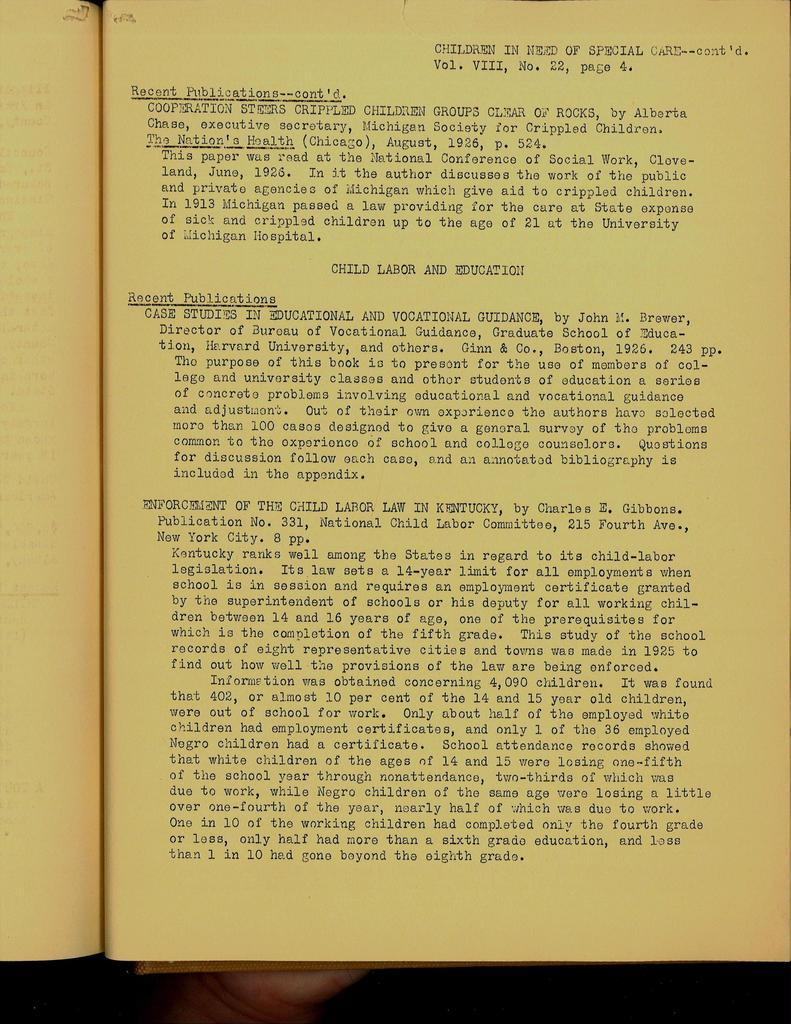Provide a one-sentence caption for the provided image. Yellowed, old type written text report about Child Labor and Education. 